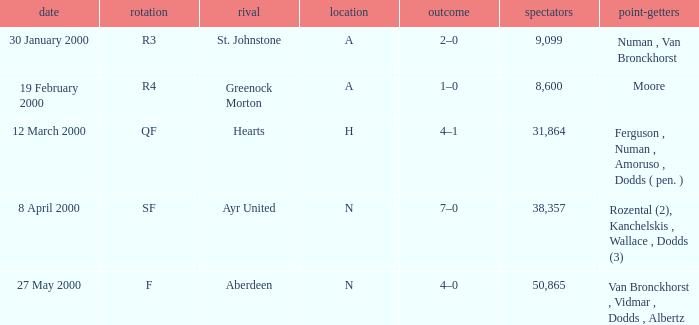Who was in a with opponent St. Johnstone? Numan , Van Bronckhorst. 